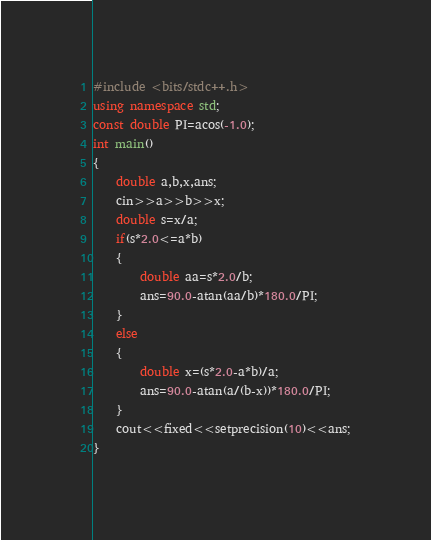<code> <loc_0><loc_0><loc_500><loc_500><_C++_>#include <bits/stdc++.h>
using namespace std;
const double PI=acos(-1.0);
int main()
{
    double a,b,x,ans;
    cin>>a>>b>>x;
    double s=x/a;
    if(s*2.0<=a*b)
    {
        double aa=s*2.0/b;
        ans=90.0-atan(aa/b)*180.0/PI;
    }
    else
	{
        double x=(s*2.0-a*b)/a;
        ans=90.0-atan(a/(b-x))*180.0/PI;
    }
    cout<<fixed<<setprecision(10)<<ans;
}</code> 